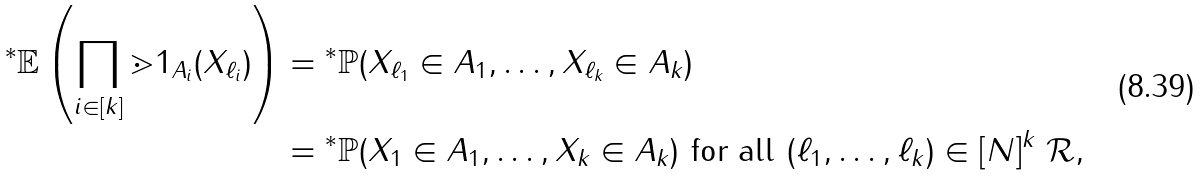Convert formula to latex. <formula><loc_0><loc_0><loc_500><loc_500>{ ^ { * } } \mathbb { E } \left ( \prod _ { i \in [ k ] } \mathbb { m } { 1 } _ { A _ { i } } ( X _ { \ell _ { i } } ) \right ) & = { ^ { * } } \mathbb { P } ( X _ { \ell _ { 1 } } \in A _ { 1 } , \dots , X _ { \ell _ { k } } \in A _ { k } ) \\ & = { ^ { * } } \mathbb { P } ( X _ { 1 } \in A _ { 1 } , \dots , X _ { k } \in A _ { k } ) \text { for all } ( \ell _ { 1 } , \dots , \ell _ { k } ) \in [ N ] ^ { k } \ \mathcal { R } ,</formula> 